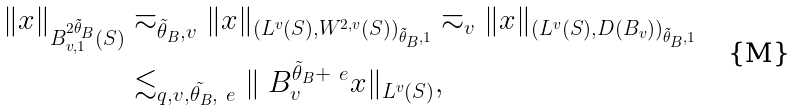<formula> <loc_0><loc_0><loc_500><loc_500>\| x \| _ { B ^ { 2 \tilde { \theta } _ { B } } _ { v , 1 } ( S ) } & \eqsim _ { \tilde { \theta } _ { B } , v } \| x \| _ { ( L ^ { v } ( S ) , W ^ { 2 , v } ( S ) ) _ { \tilde { \theta } _ { B } , 1 } } \eqsim _ { v } \| x \| _ { ( L ^ { v } ( S ) , D ( B _ { v } ) ) _ { \tilde { \theta } _ { B } , 1 } } \\ & \lesssim _ { q , v , \tilde { \theta _ { B } } , \ e } \| \ B _ { v } ^ { \tilde { \theta } _ { B } + \ e } x \| _ { L ^ { v } ( S ) } ,</formula> 